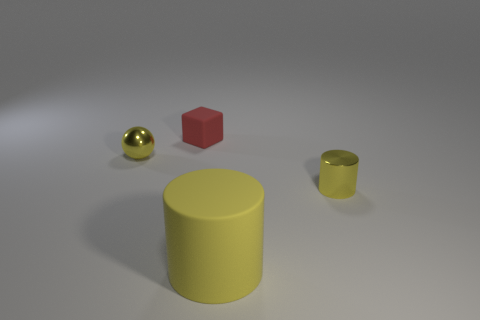There is a thing that is behind the yellow thing that is to the left of the large yellow cylinder; what is its material?
Give a very brief answer. Rubber. There is a metal object that is the same color as the tiny cylinder; what is its shape?
Provide a succinct answer. Sphere. What shape is the red rubber thing that is the same size as the metallic ball?
Your answer should be compact. Cube. Is the number of tiny gray shiny things less than the number of red objects?
Your answer should be compact. Yes. Is there a tiny red thing that is on the right side of the metal object that is on the left side of the small red rubber thing?
Ensure brevity in your answer.  Yes. What shape is the red object that is made of the same material as the big yellow object?
Provide a succinct answer. Cube. Are there any other things of the same color as the tiny matte cube?
Your answer should be very brief. No. There is a tiny yellow thing that is the same shape as the big object; what is its material?
Your answer should be compact. Metal. What number of other things are the same size as the shiny cylinder?
Offer a terse response. 2. What is the size of the ball that is the same color as the large object?
Your answer should be very brief. Small. 